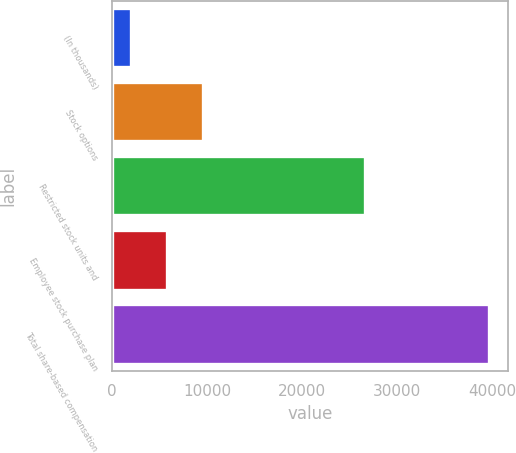Convert chart. <chart><loc_0><loc_0><loc_500><loc_500><bar_chart><fcel>(In thousands)<fcel>Stock options<fcel>Restricted stock units and<fcel>Employee stock purchase plan<fcel>Total share-based compensation<nl><fcel>2014<fcel>9538.4<fcel>26576<fcel>5776.2<fcel>39636<nl></chart> 